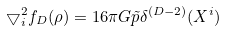<formula> <loc_0><loc_0><loc_500><loc_500>\bigtriangledown _ { i } ^ { 2 } f _ { D } ( \rho ) = 1 6 \pi G \tilde { p } \delta ^ { ( D - 2 ) } ( X ^ { i } )</formula> 